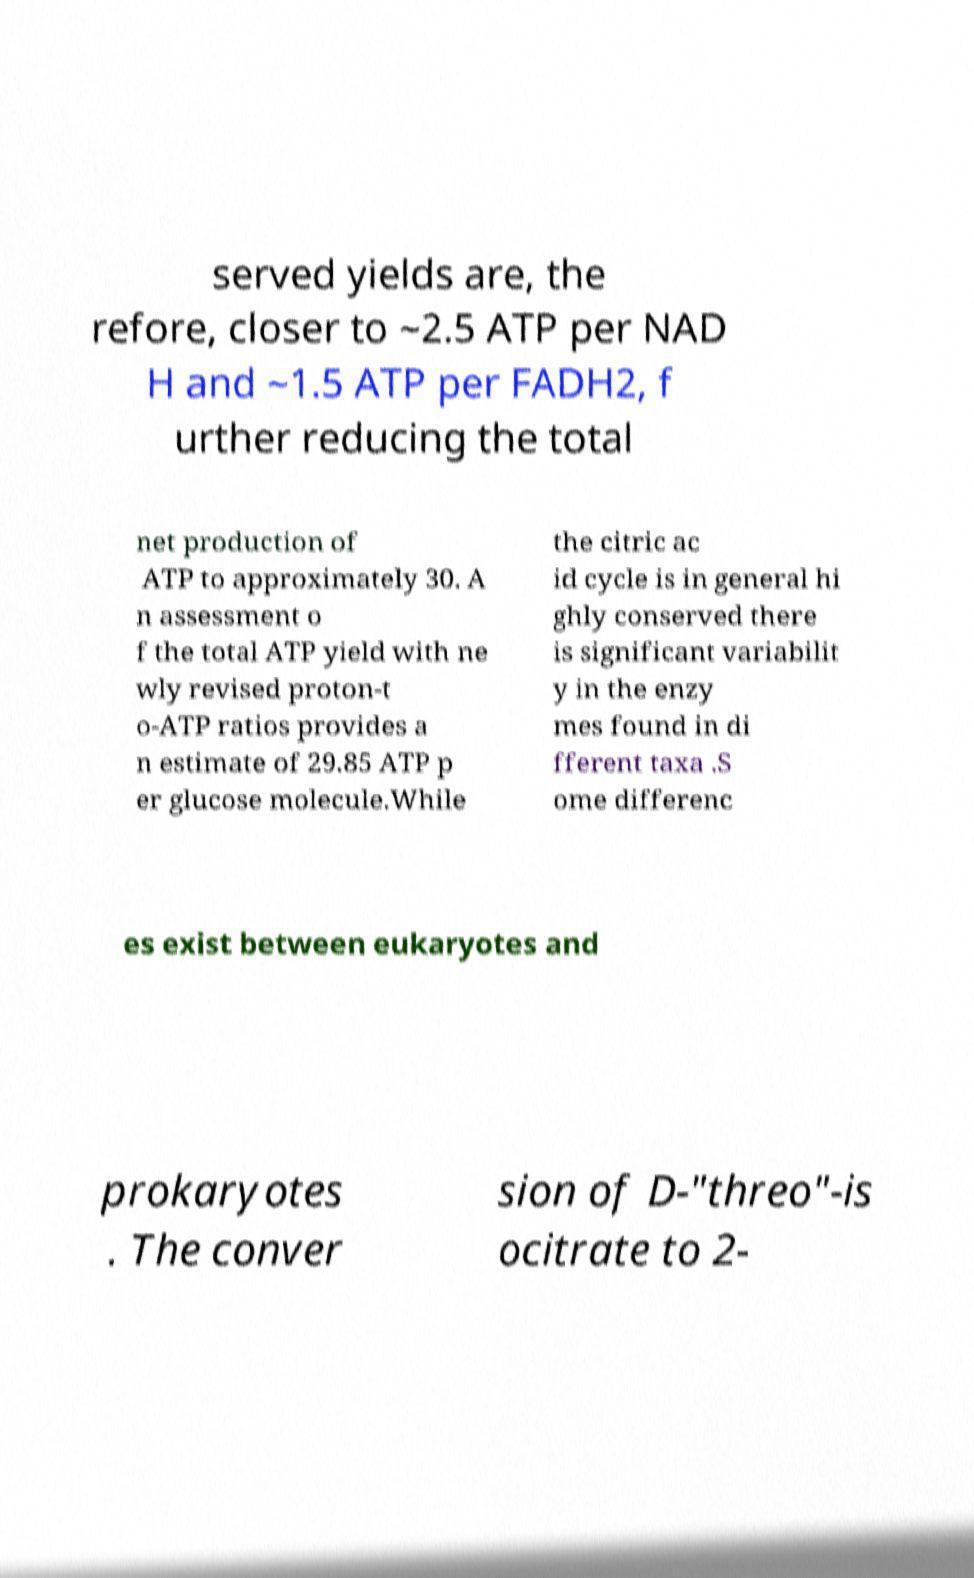For documentation purposes, I need the text within this image transcribed. Could you provide that? served yields are, the refore, closer to ~2.5 ATP per NAD H and ~1.5 ATP per FADH2, f urther reducing the total net production of ATP to approximately 30. A n assessment o f the total ATP yield with ne wly revised proton-t o-ATP ratios provides a n estimate of 29.85 ATP p er glucose molecule.While the citric ac id cycle is in general hi ghly conserved there is significant variabilit y in the enzy mes found in di fferent taxa .S ome differenc es exist between eukaryotes and prokaryotes . The conver sion of D-"threo"-is ocitrate to 2- 